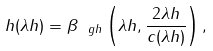Convert formula to latex. <formula><loc_0><loc_0><loc_500><loc_500>h ( \lambda h ) = \beta _ { \ g h } \left ( \lambda h , \frac { 2 \lambda h } { c ( \lambda h ) } \right ) ,</formula> 